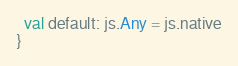<code> <loc_0><loc_0><loc_500><loc_500><_Scala_>  val default: js.Any = js.native
}
</code> 